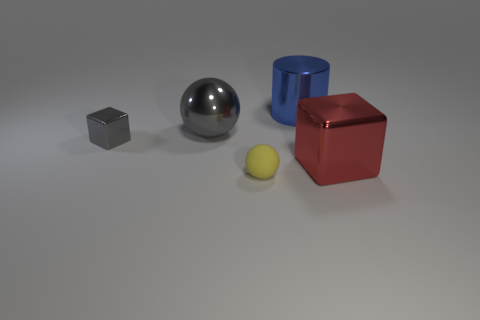Add 1 yellow balls. How many objects exist? 6 Subtract all cubes. How many objects are left? 3 Subtract 0 brown spheres. How many objects are left? 5 Subtract all tiny shiny things. Subtract all metallic blocks. How many objects are left? 2 Add 1 blue objects. How many blue objects are left? 2 Add 4 tiny metallic cubes. How many tiny metallic cubes exist? 5 